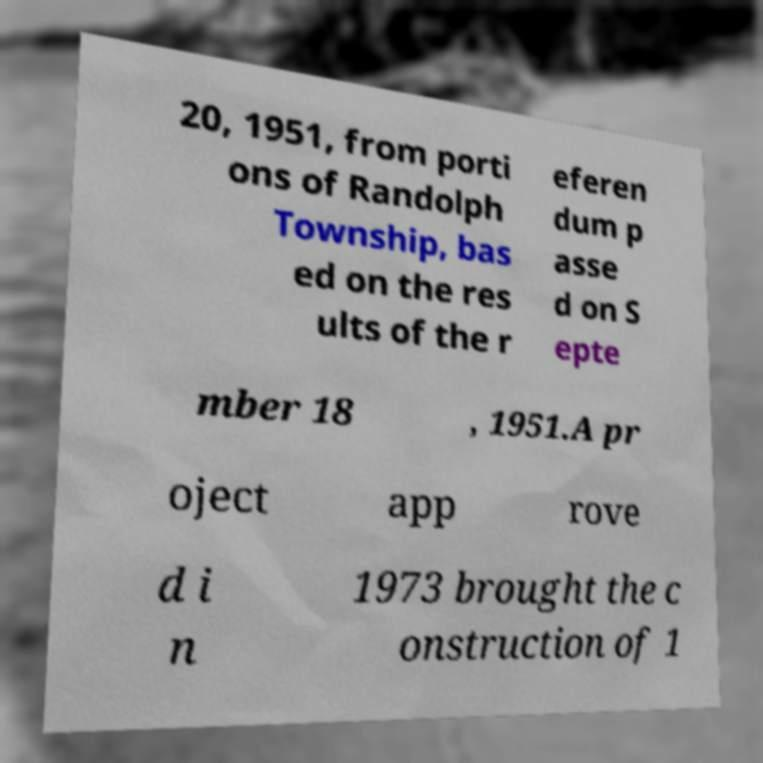Please read and relay the text visible in this image. What does it say? 20, 1951, from porti ons of Randolph Township, bas ed on the res ults of the r eferen dum p asse d on S epte mber 18 , 1951.A pr oject app rove d i n 1973 brought the c onstruction of 1 